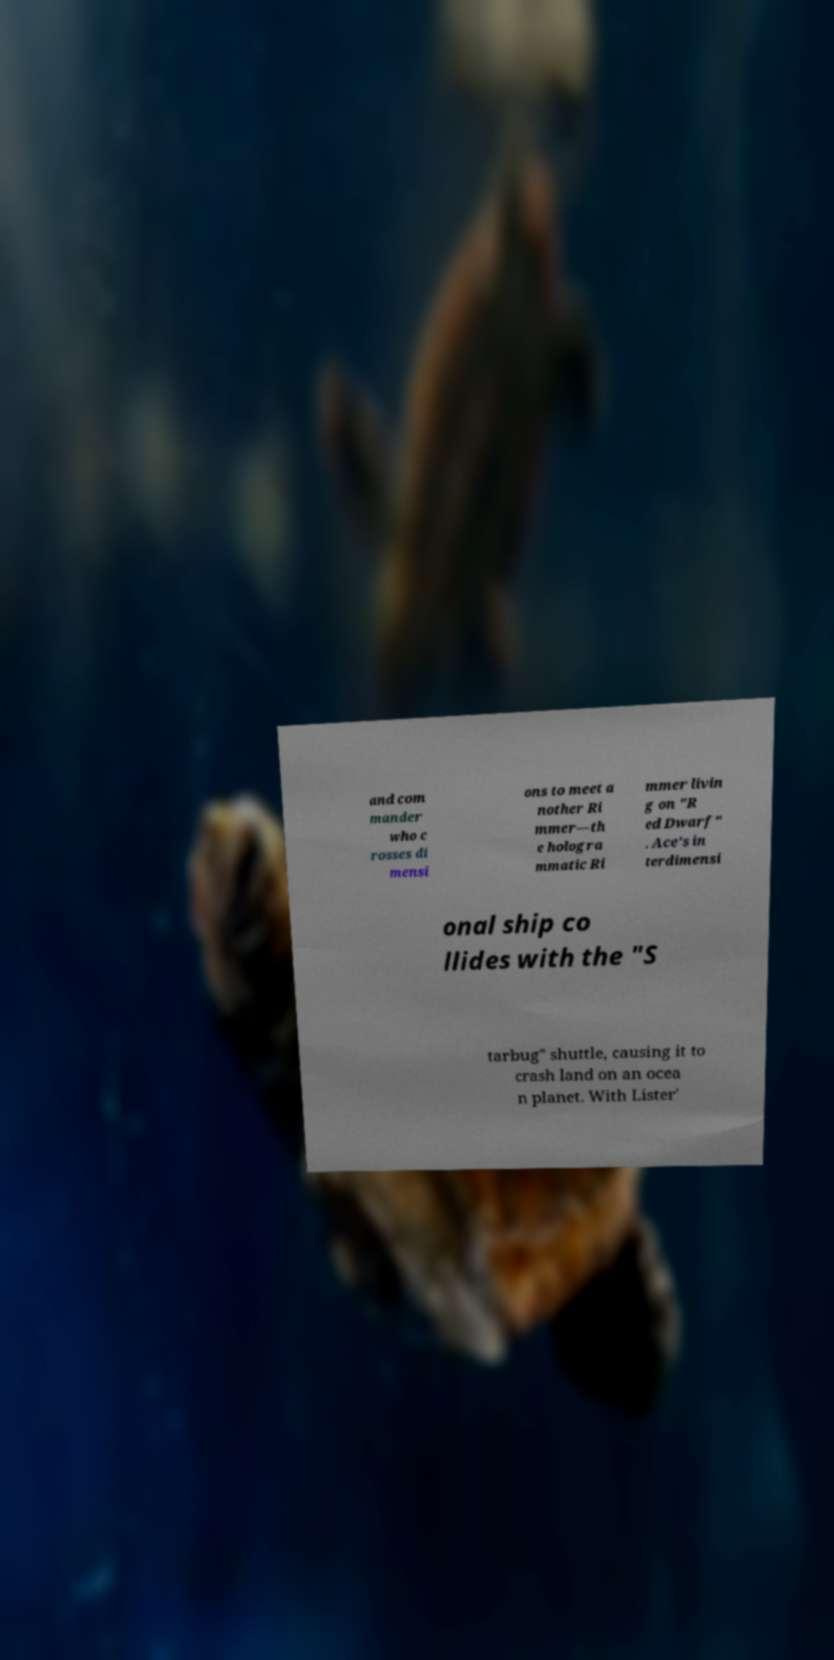There's text embedded in this image that I need extracted. Can you transcribe it verbatim? and com mander who c rosses di mensi ons to meet a nother Ri mmer—th e hologra mmatic Ri mmer livin g on "R ed Dwarf" . Ace's in terdimensi onal ship co llides with the "S tarbug" shuttle, causing it to crash land on an ocea n planet. With Lister' 